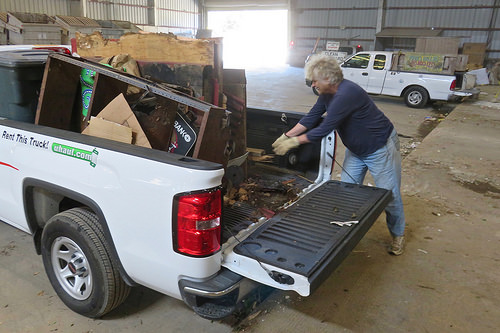<image>
Is the man to the left of the car? Yes. From this viewpoint, the man is positioned to the left side relative to the car. Is there a man to the left of the truck? Yes. From this viewpoint, the man is positioned to the left side relative to the truck. 